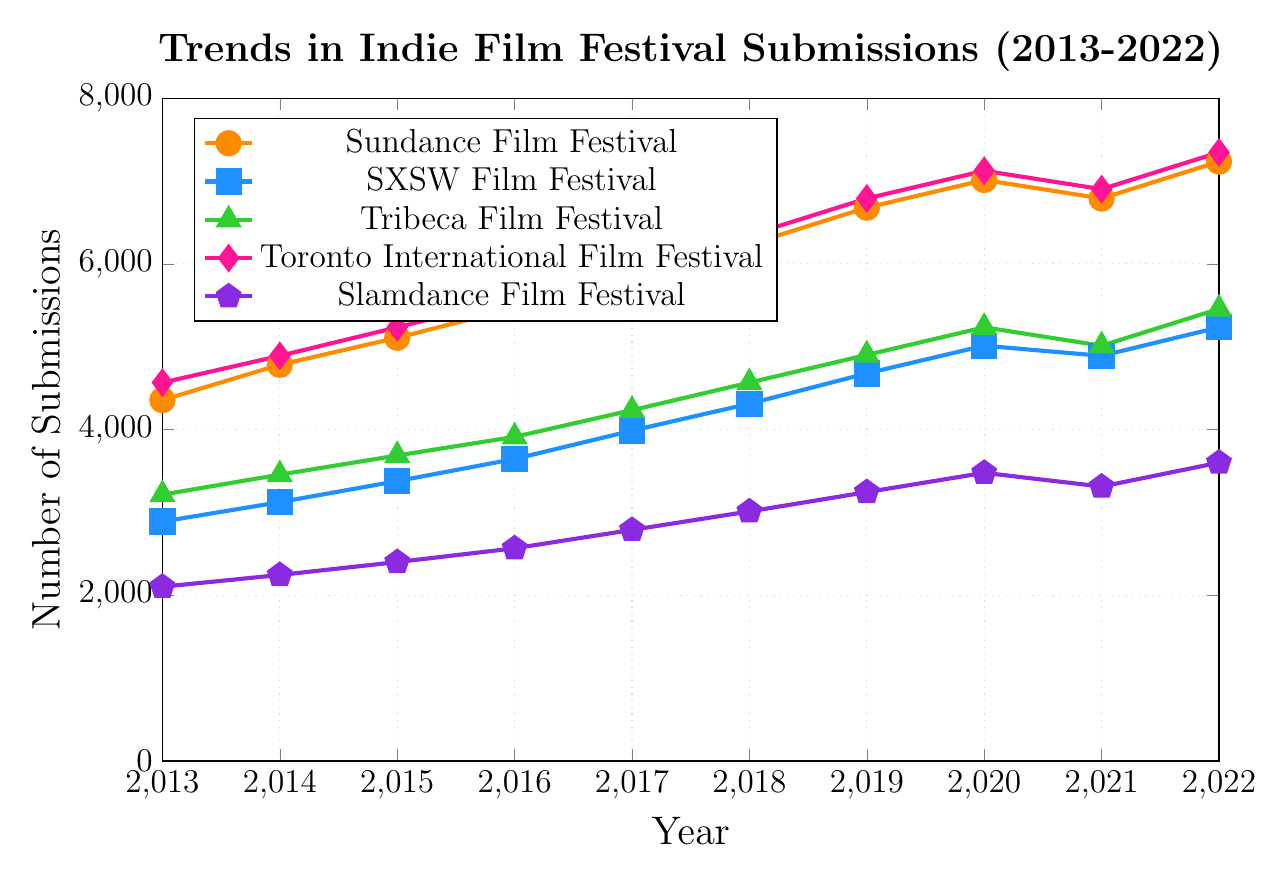Which festival had the highest number of submissions in 2022? By looking at the endpoint for 2022 on each line, the Toronto International Film Festival reached the highest number at 7345.
Answer: Toronto International Film Festival How many more submissions did Sundance Film Festival have than Tribeca Film Festival in 2022? Find the values for both festivals in 2022: Sundance (7234) and Tribeca (5456). Subtract Tribeca's number from Sundance's: 7234 - 5456 = 1778.
Answer: 1778 Which festival showed the greatest improvement in submissions from 2013 to 2022? Compute the difference in submissions for each festival from 2013 to 2022 and compare them:
- Sundance: 7234 - 4356 = 2878
- SXSW: 5234 - 2890 = 2344
- Tribeca: 5456 - 3215 = 2241
- Toronto: 7345 - 4567 = 2778
- Slamdance: 3601 - 2103 = 1498
The Sundance Film Festival had the greatest improvement.
Answer: Sundance Film Festival Did any film festival have a decrease in submissions from 2020 to 2021? If so, which one(s)? Compare the number of submissions between 2020 and 2021 for each festival:
- Sundance: 7012 to 6789 (decrease)
- SXSW: 5012 to 4890 (decrease)
- Tribeca: 5234 to 5012 (decrease)
- Toronto: 7123 to 6901 (decrease)
- Slamdance: 3478 to 3312 (decrease)
All festivals had a decrease in submissions from 2020 to 2021.
Answer: All festivals Which festival had the lowest submission numbers in 2015? By looking at the 2015 data points on the figure, Slamdance Film Festival had the lowest number of submissions at 2401.
Answer: Slamdance Film Festival What is the average number of submissions for SXSW Film Festival over the 10 years? Sum up the submissions for SXSW from 2013 to 2022 and divide by 10:
(2890 + 3124 + 3378 + 3645 + 3987 + 4312 + 4678 + 5012 + 4890 + 5234) / 10 = 4015.
Answer: 4015 Which film festivals surpassed 5000 submissions first? Examine the plot lines to see the first instance where they surpass 5000 submissions:
- Sundance: By 2015 (5108)
- SXSW: By 2020 (5012)
- Tribeca: Never surpasses 5000 until 2022 (5456)
- Toronto: By 2015 (5234)
- Slamdance: Never surpasses 5000 by 2022.
So, Sundance and Toronto surpassed 5000 first by 2015.
Answer: Sundance and Toronto International Film Festival Between 2018 and 2019, which festival had the most significant percentage increase in submissions? Calculate the percentage increase for each festival from 2018 to 2019:
- Sundance: ((6678 - 6234) / 6234) * 100 ≈ 7.11%
- SXSW: ((4678 - 4312) / 4312) * 100 ≈ 8.48%
- Tribeca: ((4901 - 4567) / 4567) * 100 ≈ 7.31%
- Toronto: ((6789 - 6345) / 6345) * 100 ≈ 7.00%
- Slamdance: ((3245 - 3012) / 3012) * 100 ≈ 7.72%
SXSW had the most significant percentage increase at approximately 8.48%.
Answer: SXSW Film Festival Which festival had the least volatile changes in submission numbers over the years? Check the visual slope changes for each festival over the years. Slamdance Film Festival has the line with the least steep slopes overall suggesting relatively stable increases.
Answer: Slamdance Film Festival 